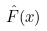<formula> <loc_0><loc_0><loc_500><loc_500>\hat { F } ( x )</formula> 